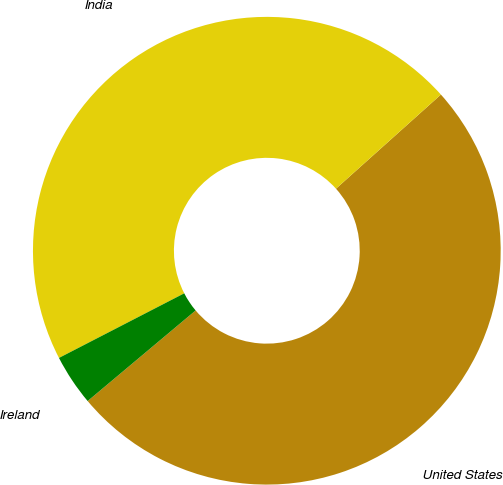Convert chart. <chart><loc_0><loc_0><loc_500><loc_500><pie_chart><fcel>United States<fcel>India<fcel>Ireland<nl><fcel>50.53%<fcel>45.94%<fcel>3.53%<nl></chart> 